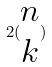Convert formula to latex. <formula><loc_0><loc_0><loc_500><loc_500>2 ( \begin{matrix} n \\ k \end{matrix} )</formula> 